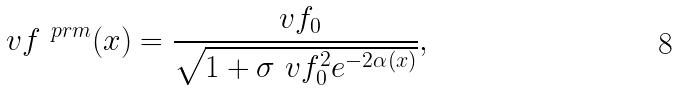<formula> <loc_0><loc_0><loc_500><loc_500>\ v f ^ { \ p r m } ( x ) = \frac { \ v f _ { 0 } } { \sqrt { 1 + \sigma \ v f _ { 0 } ^ { 2 } e ^ { - 2 \alpha ( x ) } } } ,</formula> 